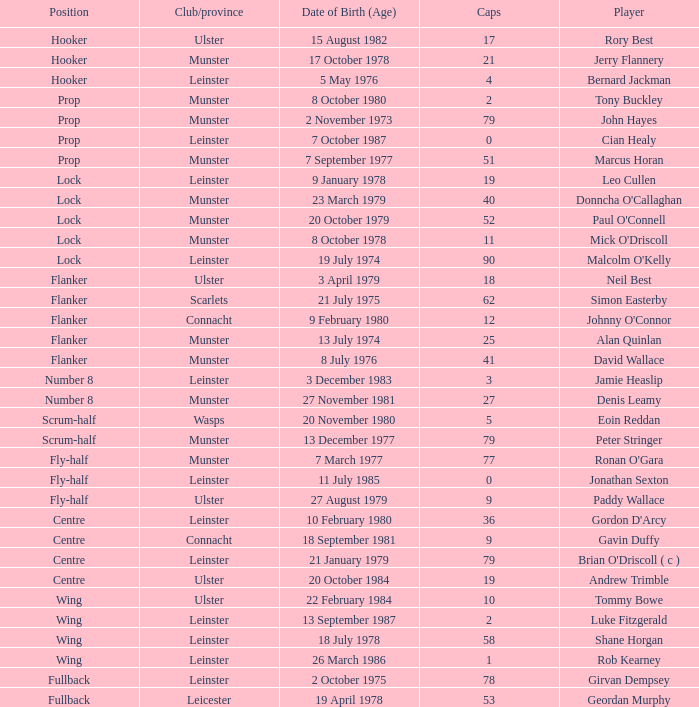What Club/province have caps less than 2 and Jonathan Sexton as player? Leinster. 